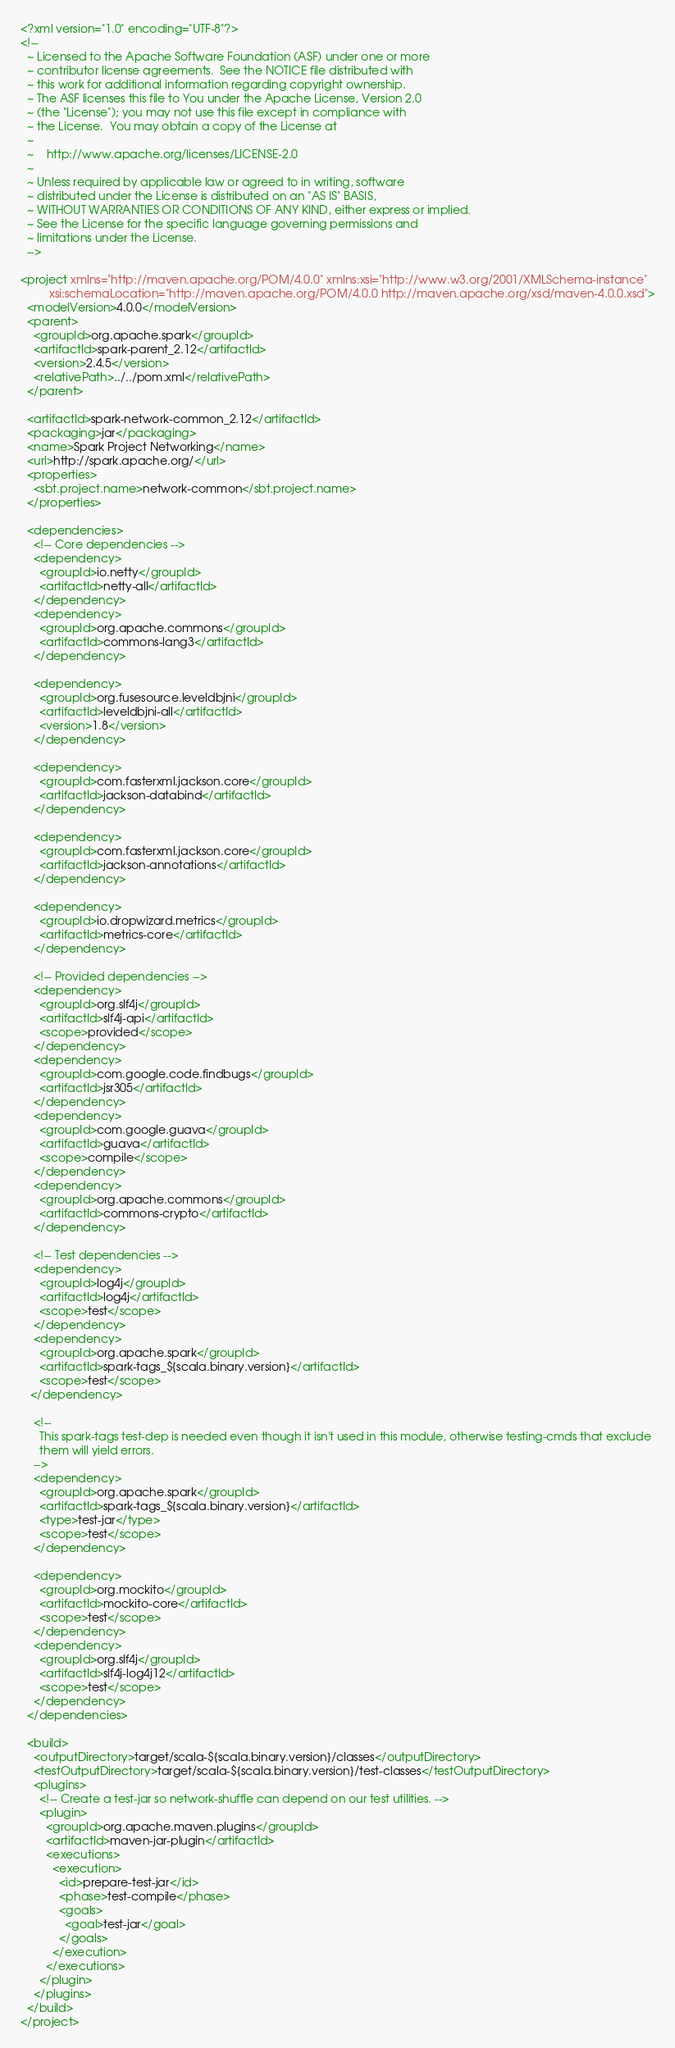Convert code to text. <code><loc_0><loc_0><loc_500><loc_500><_XML_><?xml version="1.0" encoding="UTF-8"?>
<!--
  ~ Licensed to the Apache Software Foundation (ASF) under one or more
  ~ contributor license agreements.  See the NOTICE file distributed with
  ~ this work for additional information regarding copyright ownership.
  ~ The ASF licenses this file to You under the Apache License, Version 2.0
  ~ (the "License"); you may not use this file except in compliance with
  ~ the License.  You may obtain a copy of the License at
  ~
  ~    http://www.apache.org/licenses/LICENSE-2.0
  ~
  ~ Unless required by applicable law or agreed to in writing, software
  ~ distributed under the License is distributed on an "AS IS" BASIS,
  ~ WITHOUT WARRANTIES OR CONDITIONS OF ANY KIND, either express or implied.
  ~ See the License for the specific language governing permissions and
  ~ limitations under the License.
  -->

<project xmlns="http://maven.apache.org/POM/4.0.0" xmlns:xsi="http://www.w3.org/2001/XMLSchema-instance"
         xsi:schemaLocation="http://maven.apache.org/POM/4.0.0 http://maven.apache.org/xsd/maven-4.0.0.xsd">
  <modelVersion>4.0.0</modelVersion>
  <parent>
    <groupId>org.apache.spark</groupId>
    <artifactId>spark-parent_2.12</artifactId>
    <version>2.4.5</version>
    <relativePath>../../pom.xml</relativePath>
  </parent>

  <artifactId>spark-network-common_2.12</artifactId>
  <packaging>jar</packaging>
  <name>Spark Project Networking</name>
  <url>http://spark.apache.org/</url>
  <properties>
    <sbt.project.name>network-common</sbt.project.name>
  </properties>

  <dependencies>
    <!-- Core dependencies -->
    <dependency>
      <groupId>io.netty</groupId>
      <artifactId>netty-all</artifactId>
    </dependency>
    <dependency>
      <groupId>org.apache.commons</groupId>
      <artifactId>commons-lang3</artifactId>
    </dependency>

    <dependency>
      <groupId>org.fusesource.leveldbjni</groupId>
      <artifactId>leveldbjni-all</artifactId>
      <version>1.8</version>
    </dependency>

    <dependency>
      <groupId>com.fasterxml.jackson.core</groupId>
      <artifactId>jackson-databind</artifactId>
    </dependency>

    <dependency>
      <groupId>com.fasterxml.jackson.core</groupId>
      <artifactId>jackson-annotations</artifactId>
    </dependency>

    <dependency>
      <groupId>io.dropwizard.metrics</groupId>
      <artifactId>metrics-core</artifactId>
    </dependency>

    <!-- Provided dependencies -->
    <dependency>
      <groupId>org.slf4j</groupId>
      <artifactId>slf4j-api</artifactId>
      <scope>provided</scope>
    </dependency>
    <dependency>
      <groupId>com.google.code.findbugs</groupId>
      <artifactId>jsr305</artifactId>
    </dependency>
    <dependency>
      <groupId>com.google.guava</groupId>
      <artifactId>guava</artifactId>
      <scope>compile</scope>
    </dependency>
    <dependency>
      <groupId>org.apache.commons</groupId>
      <artifactId>commons-crypto</artifactId>
    </dependency>

    <!-- Test dependencies -->
    <dependency>
      <groupId>log4j</groupId>
      <artifactId>log4j</artifactId>
      <scope>test</scope>
    </dependency>
    <dependency>
      <groupId>org.apache.spark</groupId>
      <artifactId>spark-tags_${scala.binary.version}</artifactId>
      <scope>test</scope>
   </dependency>

    <!--
      This spark-tags test-dep is needed even though it isn't used in this module, otherwise testing-cmds that exclude
      them will yield errors.
    -->
    <dependency>
      <groupId>org.apache.spark</groupId>
      <artifactId>spark-tags_${scala.binary.version}</artifactId>
      <type>test-jar</type>
      <scope>test</scope>
    </dependency>

    <dependency>
      <groupId>org.mockito</groupId>
      <artifactId>mockito-core</artifactId>
      <scope>test</scope>
    </dependency>
    <dependency>
      <groupId>org.slf4j</groupId>
      <artifactId>slf4j-log4j12</artifactId>
      <scope>test</scope>
    </dependency>
  </dependencies>

  <build>
    <outputDirectory>target/scala-${scala.binary.version}/classes</outputDirectory>
    <testOutputDirectory>target/scala-${scala.binary.version}/test-classes</testOutputDirectory>
    <plugins>
      <!-- Create a test-jar so network-shuffle can depend on our test utilities. -->
      <plugin>
        <groupId>org.apache.maven.plugins</groupId>
        <artifactId>maven-jar-plugin</artifactId>
        <executions>
          <execution>
            <id>prepare-test-jar</id>
            <phase>test-compile</phase>
            <goals>
              <goal>test-jar</goal>
            </goals>
          </execution>
        </executions>
      </plugin>
    </plugins>
  </build>
</project>
</code> 